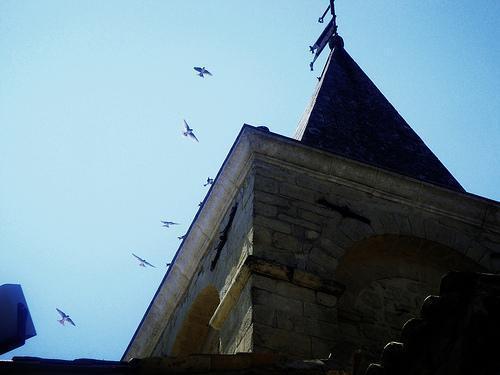How many buildings are there?
Give a very brief answer. 1. 